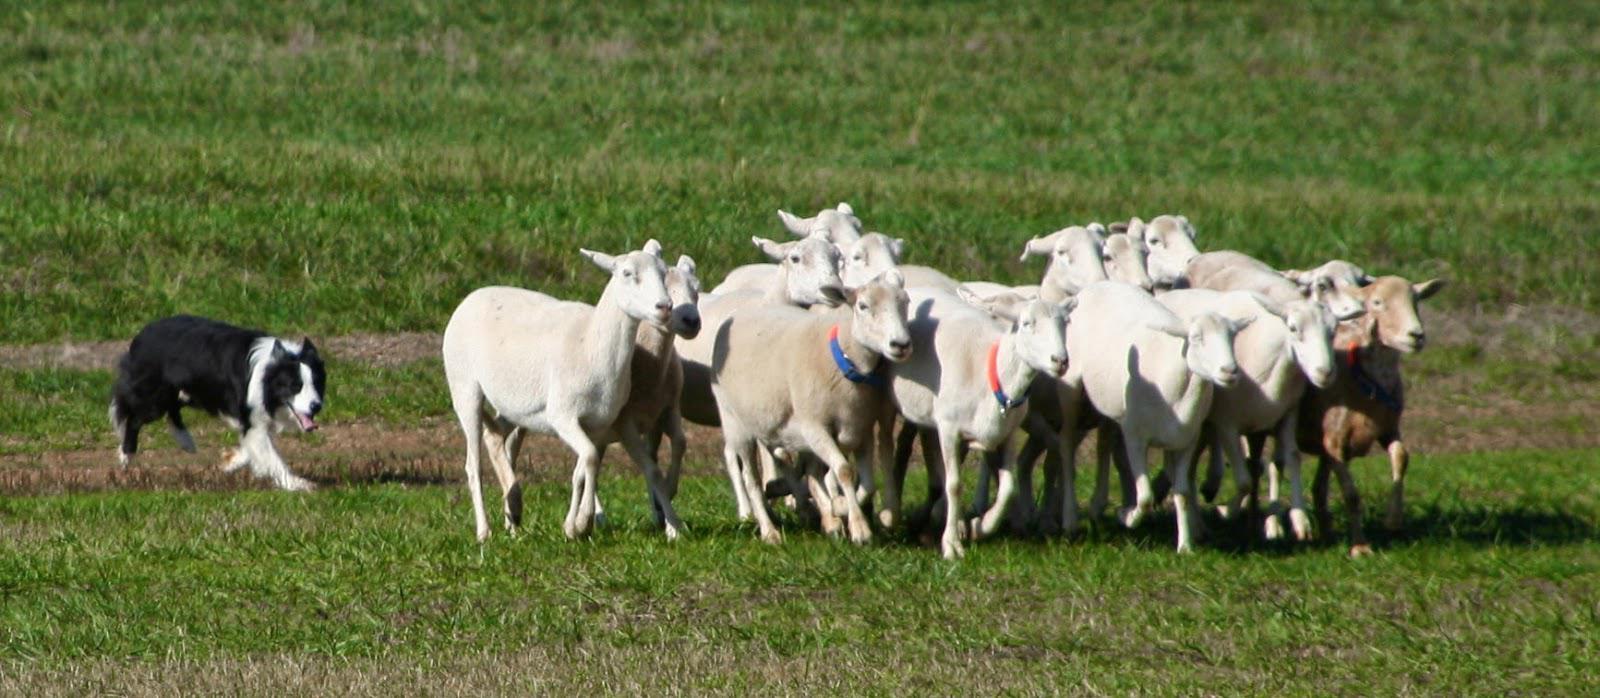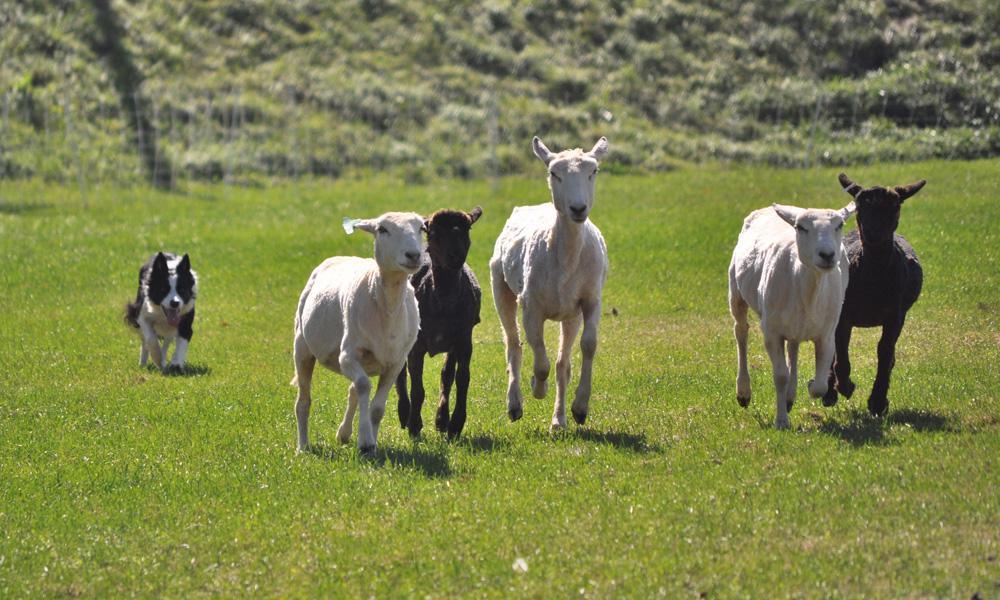The first image is the image on the left, the second image is the image on the right. Considering the images on both sides, is "One image has exactly three dogs." valid? Answer yes or no. No. 